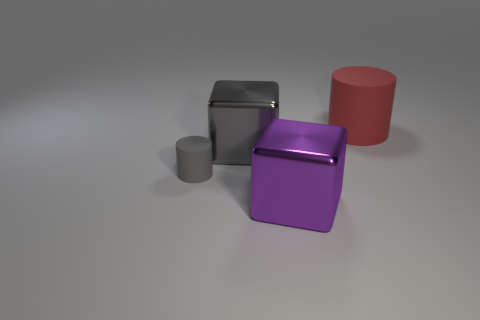Is the shape of the purple thing the same as the rubber thing in front of the red thing?
Provide a succinct answer. No. Is there anything else that has the same size as the gray matte object?
Offer a terse response. No. What size is the purple object that is the same shape as the big gray shiny object?
Give a very brief answer. Large. Is the number of large yellow balls greater than the number of purple things?
Offer a terse response. No. Do the big gray metallic thing and the tiny gray matte thing have the same shape?
Your answer should be compact. No. There is a block that is in front of the block behind the gray cylinder; what is it made of?
Offer a terse response. Metal. What material is the cube that is the same color as the tiny cylinder?
Provide a short and direct response. Metal. Do the red matte thing and the gray rubber thing have the same size?
Your response must be concise. No. Are there any tiny matte objects right of the matte cylinder in front of the large red rubber object?
Your answer should be compact. No. What is the shape of the large metallic object in front of the large gray metallic cube?
Offer a very short reply. Cube. 